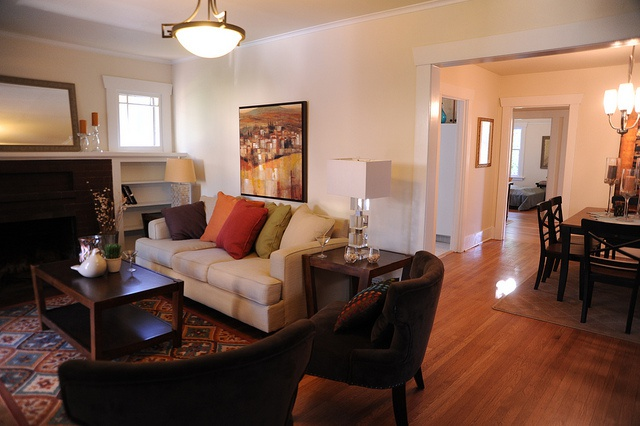Describe the objects in this image and their specific colors. I can see couch in black, darkgray, gray, tan, and maroon tones, chair in black, maroon, and brown tones, chair in black, maroon, and gray tones, tv in black, darkgray, tan, and maroon tones, and chair in black, brown, and maroon tones in this image. 